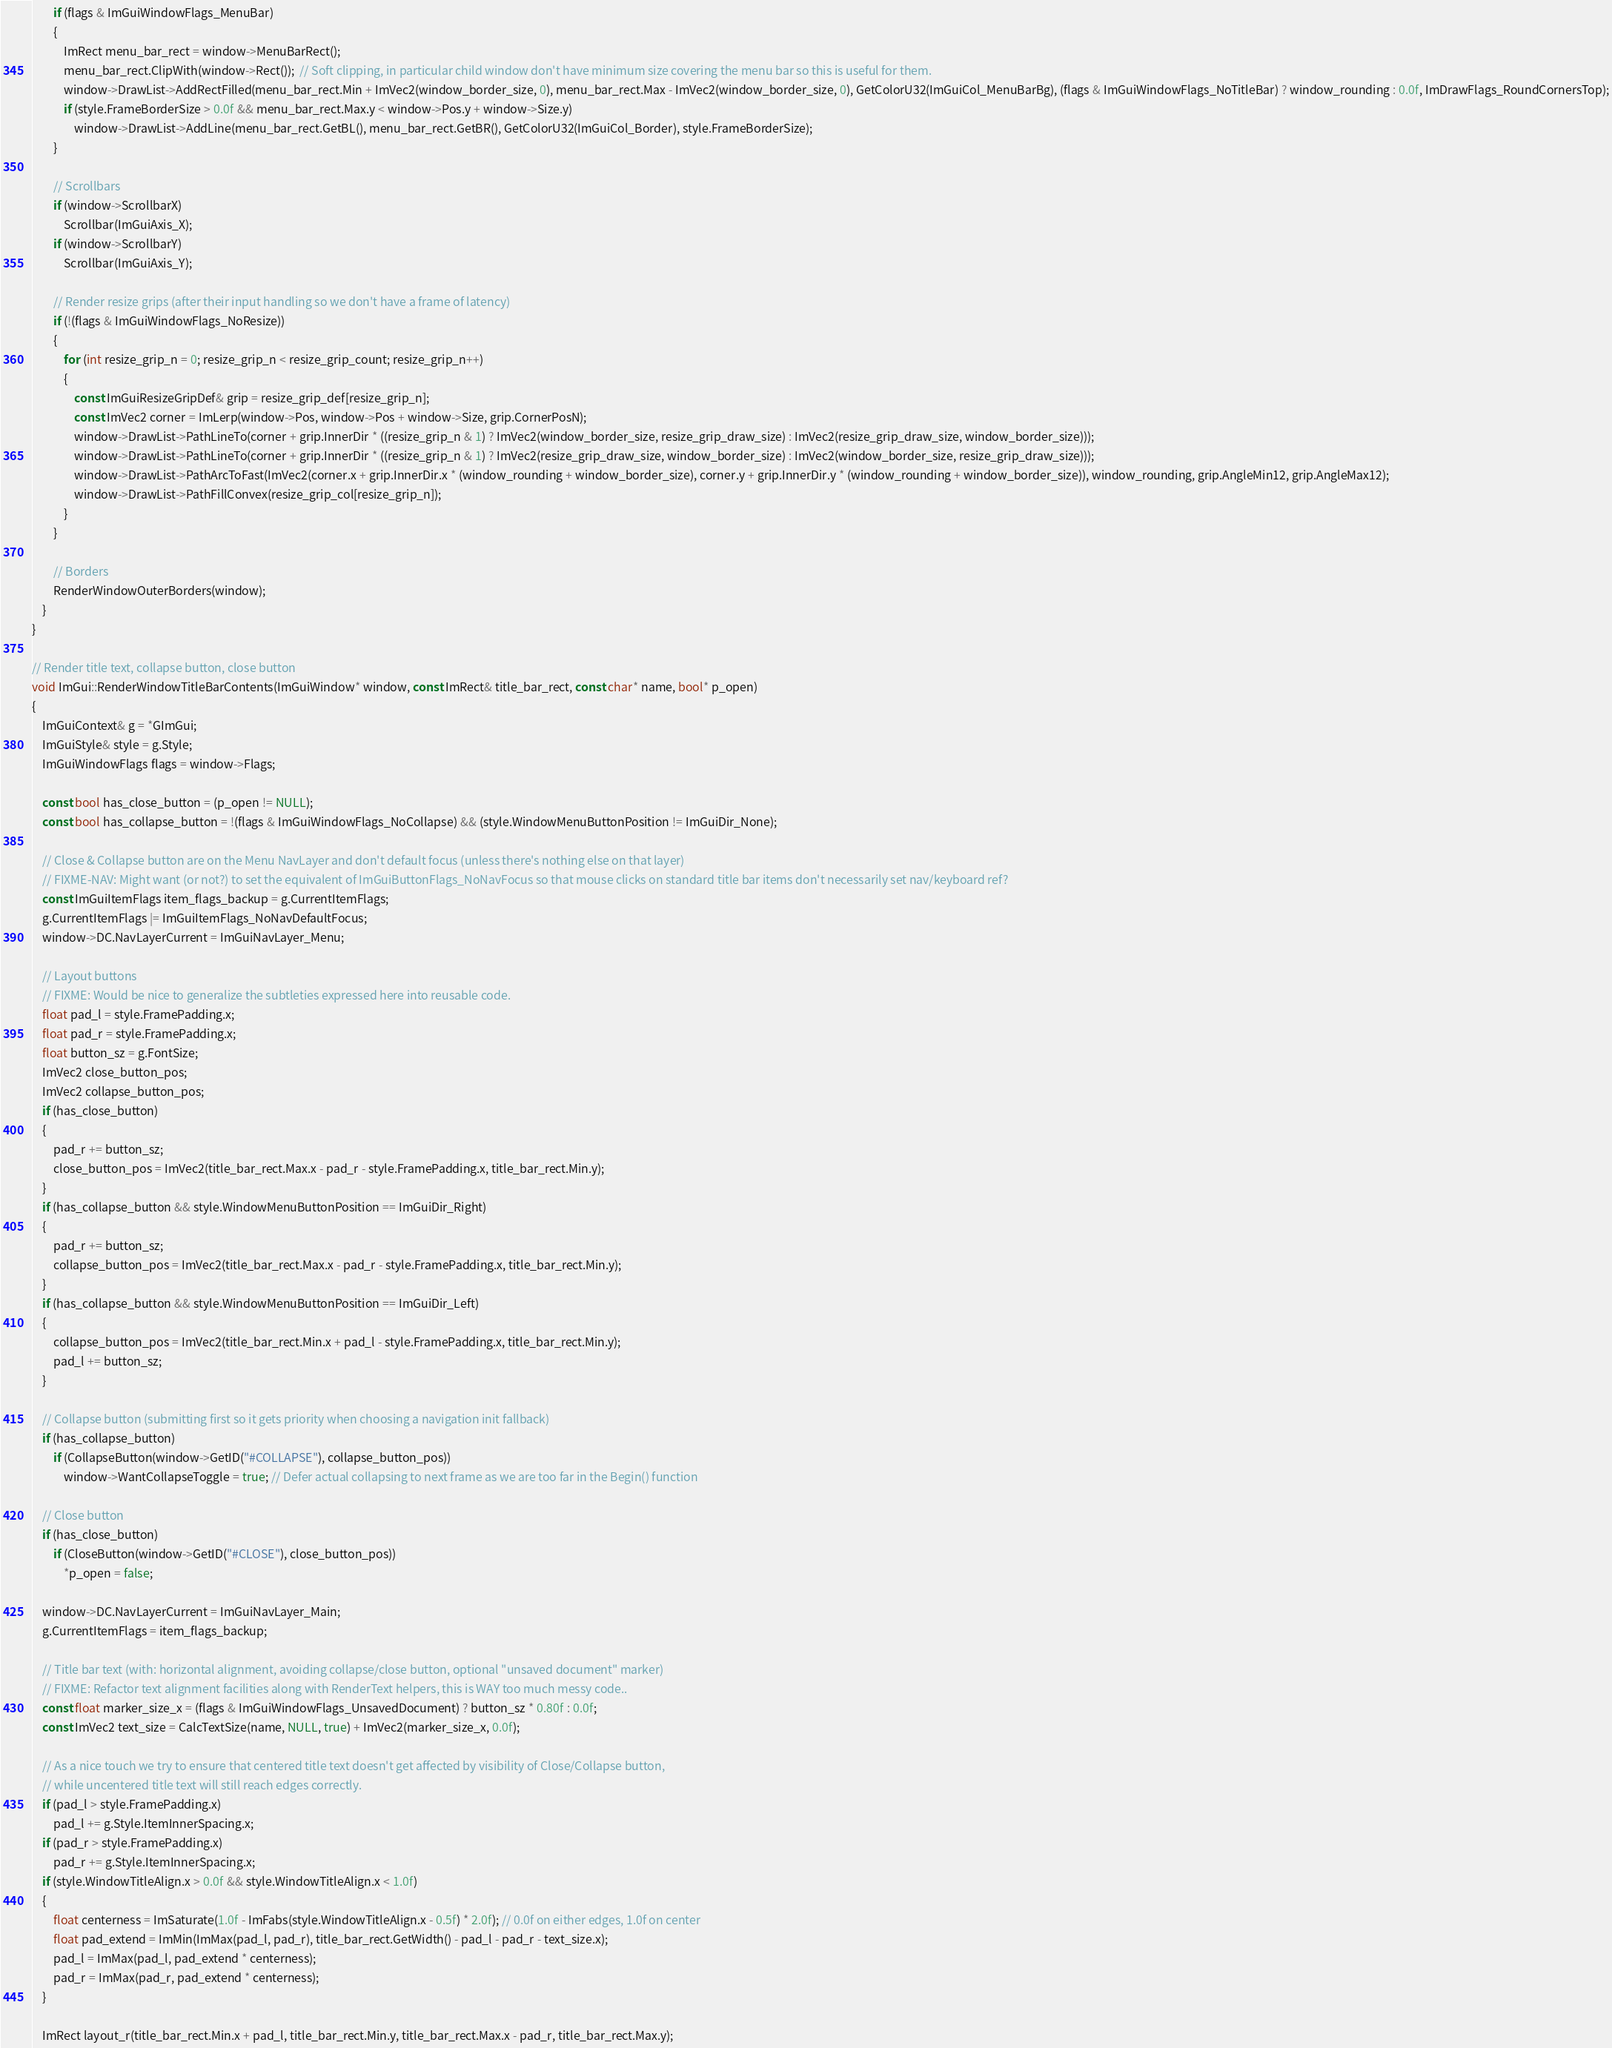Convert code to text. <code><loc_0><loc_0><loc_500><loc_500><_C++_>        if (flags & ImGuiWindowFlags_MenuBar)
        {
            ImRect menu_bar_rect = window->MenuBarRect();
            menu_bar_rect.ClipWith(window->Rect());  // Soft clipping, in particular child window don't have minimum size covering the menu bar so this is useful for them.
            window->DrawList->AddRectFilled(menu_bar_rect.Min + ImVec2(window_border_size, 0), menu_bar_rect.Max - ImVec2(window_border_size, 0), GetColorU32(ImGuiCol_MenuBarBg), (flags & ImGuiWindowFlags_NoTitleBar) ? window_rounding : 0.0f, ImDrawFlags_RoundCornersTop);
            if (style.FrameBorderSize > 0.0f && menu_bar_rect.Max.y < window->Pos.y + window->Size.y)
                window->DrawList->AddLine(menu_bar_rect.GetBL(), menu_bar_rect.GetBR(), GetColorU32(ImGuiCol_Border), style.FrameBorderSize);
        }

        // Scrollbars
        if (window->ScrollbarX)
            Scrollbar(ImGuiAxis_X);
        if (window->ScrollbarY)
            Scrollbar(ImGuiAxis_Y);

        // Render resize grips (after their input handling so we don't have a frame of latency)
        if (!(flags & ImGuiWindowFlags_NoResize))
        {
            for (int resize_grip_n = 0; resize_grip_n < resize_grip_count; resize_grip_n++)
            {
                const ImGuiResizeGripDef& grip = resize_grip_def[resize_grip_n];
                const ImVec2 corner = ImLerp(window->Pos, window->Pos + window->Size, grip.CornerPosN);
                window->DrawList->PathLineTo(corner + grip.InnerDir * ((resize_grip_n & 1) ? ImVec2(window_border_size, resize_grip_draw_size) : ImVec2(resize_grip_draw_size, window_border_size)));
                window->DrawList->PathLineTo(corner + grip.InnerDir * ((resize_grip_n & 1) ? ImVec2(resize_grip_draw_size, window_border_size) : ImVec2(window_border_size, resize_grip_draw_size)));
                window->DrawList->PathArcToFast(ImVec2(corner.x + grip.InnerDir.x * (window_rounding + window_border_size), corner.y + grip.InnerDir.y * (window_rounding + window_border_size)), window_rounding, grip.AngleMin12, grip.AngleMax12);
                window->DrawList->PathFillConvex(resize_grip_col[resize_grip_n]);
            }
        }

        // Borders
        RenderWindowOuterBorders(window);
    }
}

// Render title text, collapse button, close button
void ImGui::RenderWindowTitleBarContents(ImGuiWindow* window, const ImRect& title_bar_rect, const char* name, bool* p_open)
{
    ImGuiContext& g = *GImGui;
    ImGuiStyle& style = g.Style;
    ImGuiWindowFlags flags = window->Flags;

    const bool has_close_button = (p_open != NULL);
    const bool has_collapse_button = !(flags & ImGuiWindowFlags_NoCollapse) && (style.WindowMenuButtonPosition != ImGuiDir_None);

    // Close & Collapse button are on the Menu NavLayer and don't default focus (unless there's nothing else on that layer)
    // FIXME-NAV: Might want (or not?) to set the equivalent of ImGuiButtonFlags_NoNavFocus so that mouse clicks on standard title bar items don't necessarily set nav/keyboard ref?
    const ImGuiItemFlags item_flags_backup = g.CurrentItemFlags;
    g.CurrentItemFlags |= ImGuiItemFlags_NoNavDefaultFocus;
    window->DC.NavLayerCurrent = ImGuiNavLayer_Menu;

    // Layout buttons
    // FIXME: Would be nice to generalize the subtleties expressed here into reusable code.
    float pad_l = style.FramePadding.x;
    float pad_r = style.FramePadding.x;
    float button_sz = g.FontSize;
    ImVec2 close_button_pos;
    ImVec2 collapse_button_pos;
    if (has_close_button)
    {
        pad_r += button_sz;
        close_button_pos = ImVec2(title_bar_rect.Max.x - pad_r - style.FramePadding.x, title_bar_rect.Min.y);
    }
    if (has_collapse_button && style.WindowMenuButtonPosition == ImGuiDir_Right)
    {
        pad_r += button_sz;
        collapse_button_pos = ImVec2(title_bar_rect.Max.x - pad_r - style.FramePadding.x, title_bar_rect.Min.y);
    }
    if (has_collapse_button && style.WindowMenuButtonPosition == ImGuiDir_Left)
    {
        collapse_button_pos = ImVec2(title_bar_rect.Min.x + pad_l - style.FramePadding.x, title_bar_rect.Min.y);
        pad_l += button_sz;
    }

    // Collapse button (submitting first so it gets priority when choosing a navigation init fallback)
    if (has_collapse_button)
        if (CollapseButton(window->GetID("#COLLAPSE"), collapse_button_pos))
            window->WantCollapseToggle = true; // Defer actual collapsing to next frame as we are too far in the Begin() function

    // Close button
    if (has_close_button)
        if (CloseButton(window->GetID("#CLOSE"), close_button_pos))
            *p_open = false;

    window->DC.NavLayerCurrent = ImGuiNavLayer_Main;
    g.CurrentItemFlags = item_flags_backup;

    // Title bar text (with: horizontal alignment, avoiding collapse/close button, optional "unsaved document" marker)
    // FIXME: Refactor text alignment facilities along with RenderText helpers, this is WAY too much messy code..
    const float marker_size_x = (flags & ImGuiWindowFlags_UnsavedDocument) ? button_sz * 0.80f : 0.0f;
    const ImVec2 text_size = CalcTextSize(name, NULL, true) + ImVec2(marker_size_x, 0.0f);

    // As a nice touch we try to ensure that centered title text doesn't get affected by visibility of Close/Collapse button,
    // while uncentered title text will still reach edges correctly.
    if (pad_l > style.FramePadding.x)
        pad_l += g.Style.ItemInnerSpacing.x;
    if (pad_r > style.FramePadding.x)
        pad_r += g.Style.ItemInnerSpacing.x;
    if (style.WindowTitleAlign.x > 0.0f && style.WindowTitleAlign.x < 1.0f)
    {
        float centerness = ImSaturate(1.0f - ImFabs(style.WindowTitleAlign.x - 0.5f) * 2.0f); // 0.0f on either edges, 1.0f on center
        float pad_extend = ImMin(ImMax(pad_l, pad_r), title_bar_rect.GetWidth() - pad_l - pad_r - text_size.x);
        pad_l = ImMax(pad_l, pad_extend * centerness);
        pad_r = ImMax(pad_r, pad_extend * centerness);
    }

    ImRect layout_r(title_bar_rect.Min.x + pad_l, title_bar_rect.Min.y, title_bar_rect.Max.x - pad_r, title_bar_rect.Max.y);</code> 